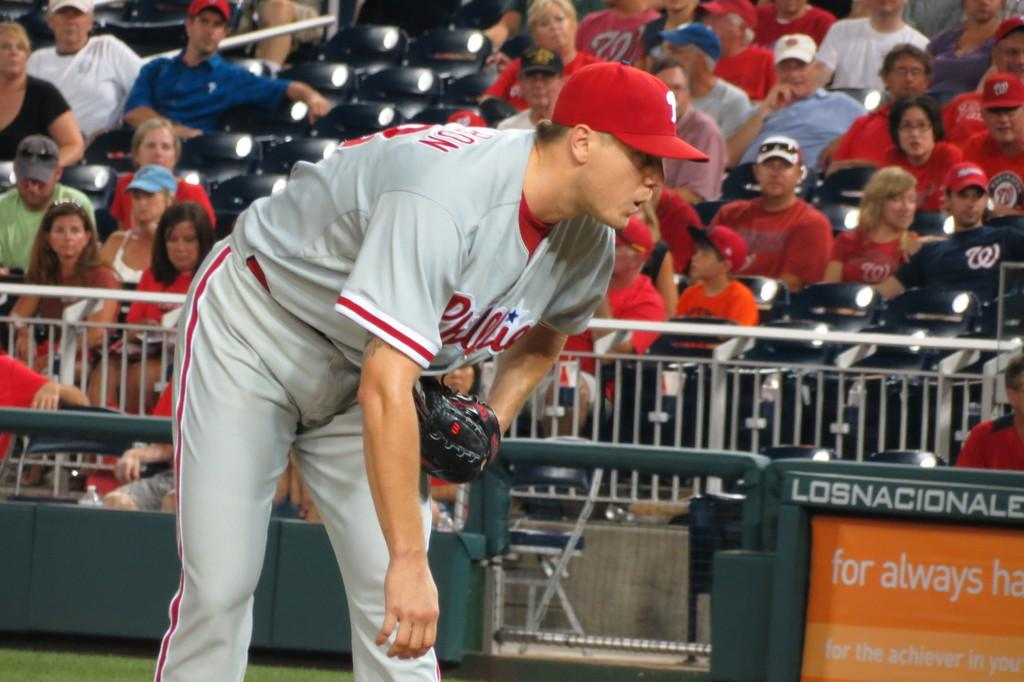<image>
Describe the image concisely. A baseman paying close attention the field play at the Los Nacionales stadium. 